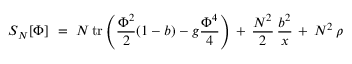Convert formula to latex. <formula><loc_0><loc_0><loc_500><loc_500>S _ { N } [ \Phi ] \ = \ N \, t r \left ( { \frac { \Phi ^ { 2 } } { 2 } } ( 1 - b ) - g { \frac { \Phi ^ { 4 } } { 4 } } \right ) \, + \, { \frac { N ^ { 2 } } { 2 } } \, { \frac { b ^ { 2 } } { x } } \, + \, N ^ { 2 } \, \rho</formula> 